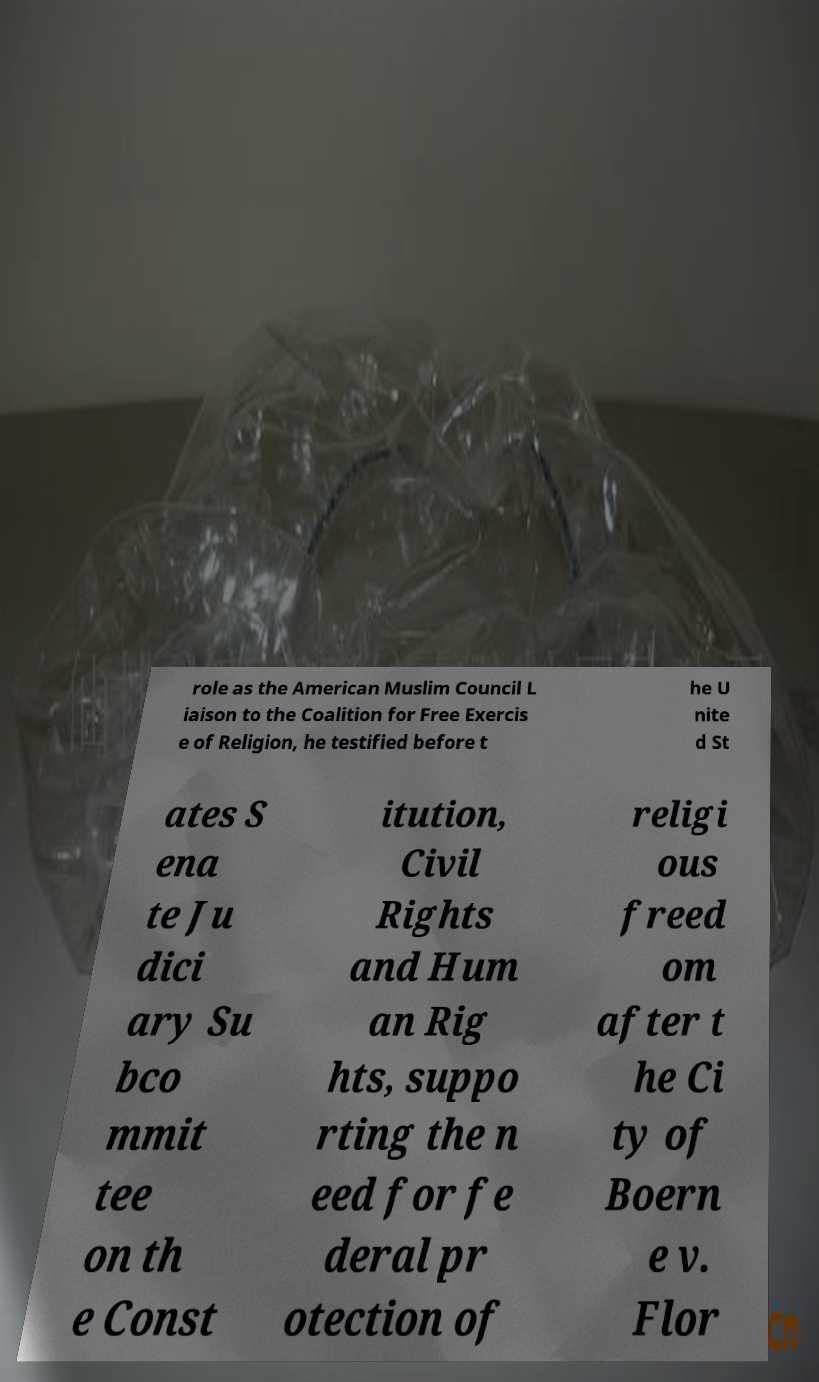There's text embedded in this image that I need extracted. Can you transcribe it verbatim? role as the American Muslim Council L iaison to the Coalition for Free Exercis e of Religion, he testified before t he U nite d St ates S ena te Ju dici ary Su bco mmit tee on th e Const itution, Civil Rights and Hum an Rig hts, suppo rting the n eed for fe deral pr otection of religi ous freed om after t he Ci ty of Boern e v. Flor 